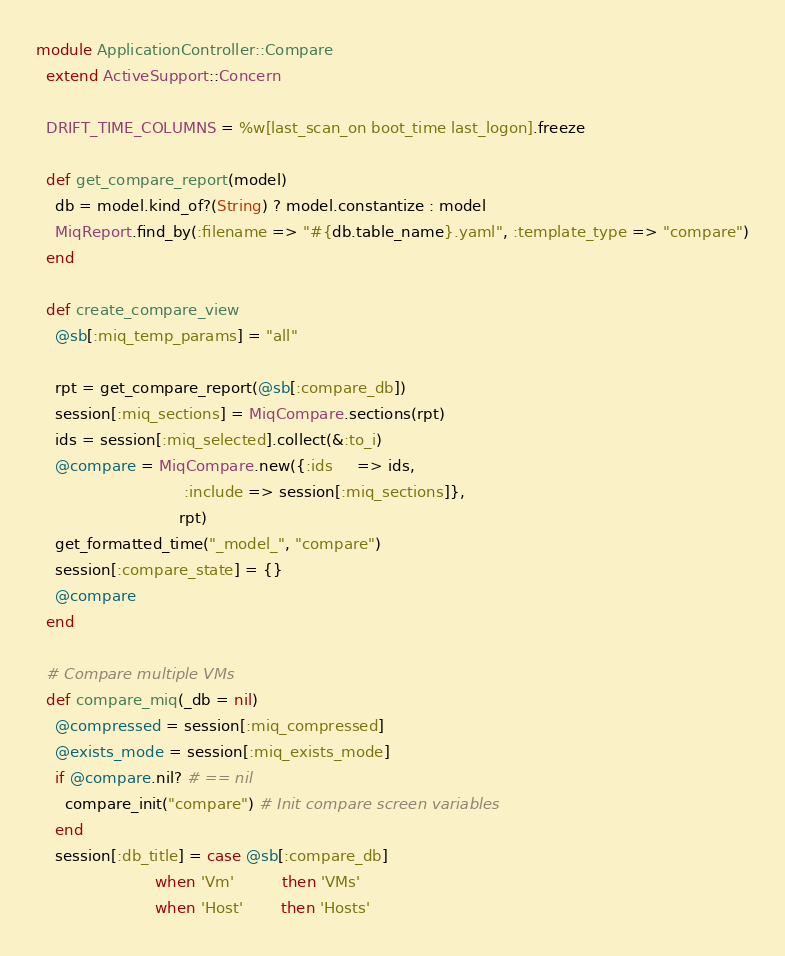Convert code to text. <code><loc_0><loc_0><loc_500><loc_500><_Ruby_>module ApplicationController::Compare
  extend ActiveSupport::Concern

  DRIFT_TIME_COLUMNS = %w[last_scan_on boot_time last_logon].freeze

  def get_compare_report(model)
    db = model.kind_of?(String) ? model.constantize : model
    MiqReport.find_by(:filename => "#{db.table_name}.yaml", :template_type => "compare")
  end

  def create_compare_view
    @sb[:miq_temp_params] = "all"

    rpt = get_compare_report(@sb[:compare_db])
    session[:miq_sections] = MiqCompare.sections(rpt)
    ids = session[:miq_selected].collect(&:to_i)
    @compare = MiqCompare.new({:ids     => ids,
                               :include => session[:miq_sections]},
                              rpt)
    get_formatted_time("_model_", "compare")
    session[:compare_state] = {}
    @compare
  end

  # Compare multiple VMs
  def compare_miq(_db = nil)
    @compressed = session[:miq_compressed]
    @exists_mode = session[:miq_exists_mode]
    if @compare.nil? # == nil
      compare_init("compare") # Init compare screen variables
    end
    session[:db_title] = case @sb[:compare_db]
                         when 'Vm'          then 'VMs'
                         when 'Host'        then 'Hosts'</code> 